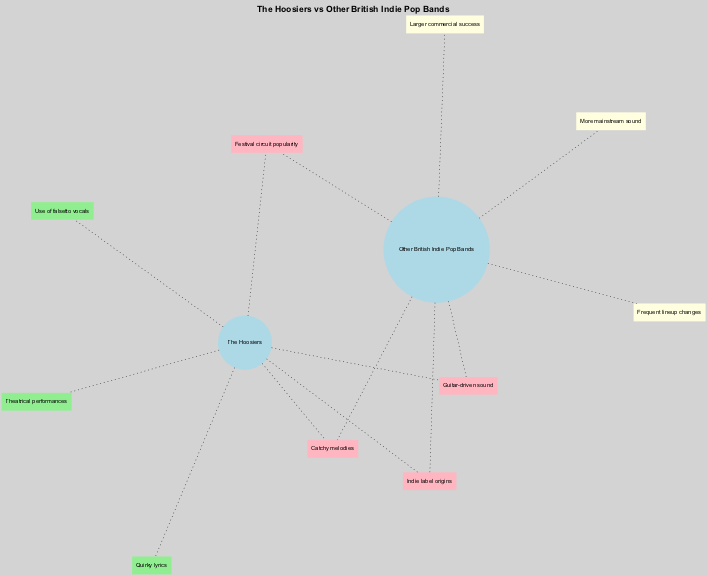What unique element is listed under The Hoosiers? The diagram shows a unique element labeled "Quirky lyrics" specifically associated with The Hoosiers. Therefore, it's a distinctive feature exclusive to this band and not present in the overlapping section.
Answer: Quirky lyrics How many unique elements are listed for Other British Indie Pop Bands? The diagram presents three unique elements under the section for Other British Indie Pop Bands: "More mainstream sound," "Larger commercial success," and "Frequent lineup changes." Counting these yields a total of three unique elements.
Answer: 3 What overlapping element relates to the sound of the bands? The diagram includes "Guitar-driven sound" as one of the overlapping elements, indicating that both The Hoosiers and other contemporary British indie pop bands share this characteristic.
Answer: Guitar-driven sound Which band has theatrical performances as a unique element? According to the diagram, the unique element "Theatrical performances" is specifically cited under The Hoosiers, indicating their distinct performance style.
Answer: The Hoosiers What is the total number of unique elements listed in the diagram? By analyzing both circles in the diagram: The Hoosiers have three unique elements, and Other British Indie Pop Bands have three unique elements as well. Adding these gives a total of six unique elements (3 + 3).
Answer: 6 Which unique element distinguishes The Hoosiers from Other British Indie Pop Bands? The unique element "Use of falsetto vocals" is highlighted under The Hoosiers, setting them apart from the other bands, which do not share this characteristic.
Answer: Use of falsetto vocals How many overlapping elements are shared between The Hoosiers and Other British Indie Pop Bands? The diagram illustrates four overlapping elements, which are "Catchy melodies," "Guitar-driven sound," "Indie label origins," and "Festival circuit popularity." Thus, the total count is four shared elements.
Answer: 4 What is one aspect where Other British Indie Pop Bands stand out compared to The Hoosiers? The element "Larger commercial success" specifically points out that Other British Indie Pop Bands typically achieve greater commercial success than The Hoosiers, distinguishing them in this regard.
Answer: Larger commercial success 